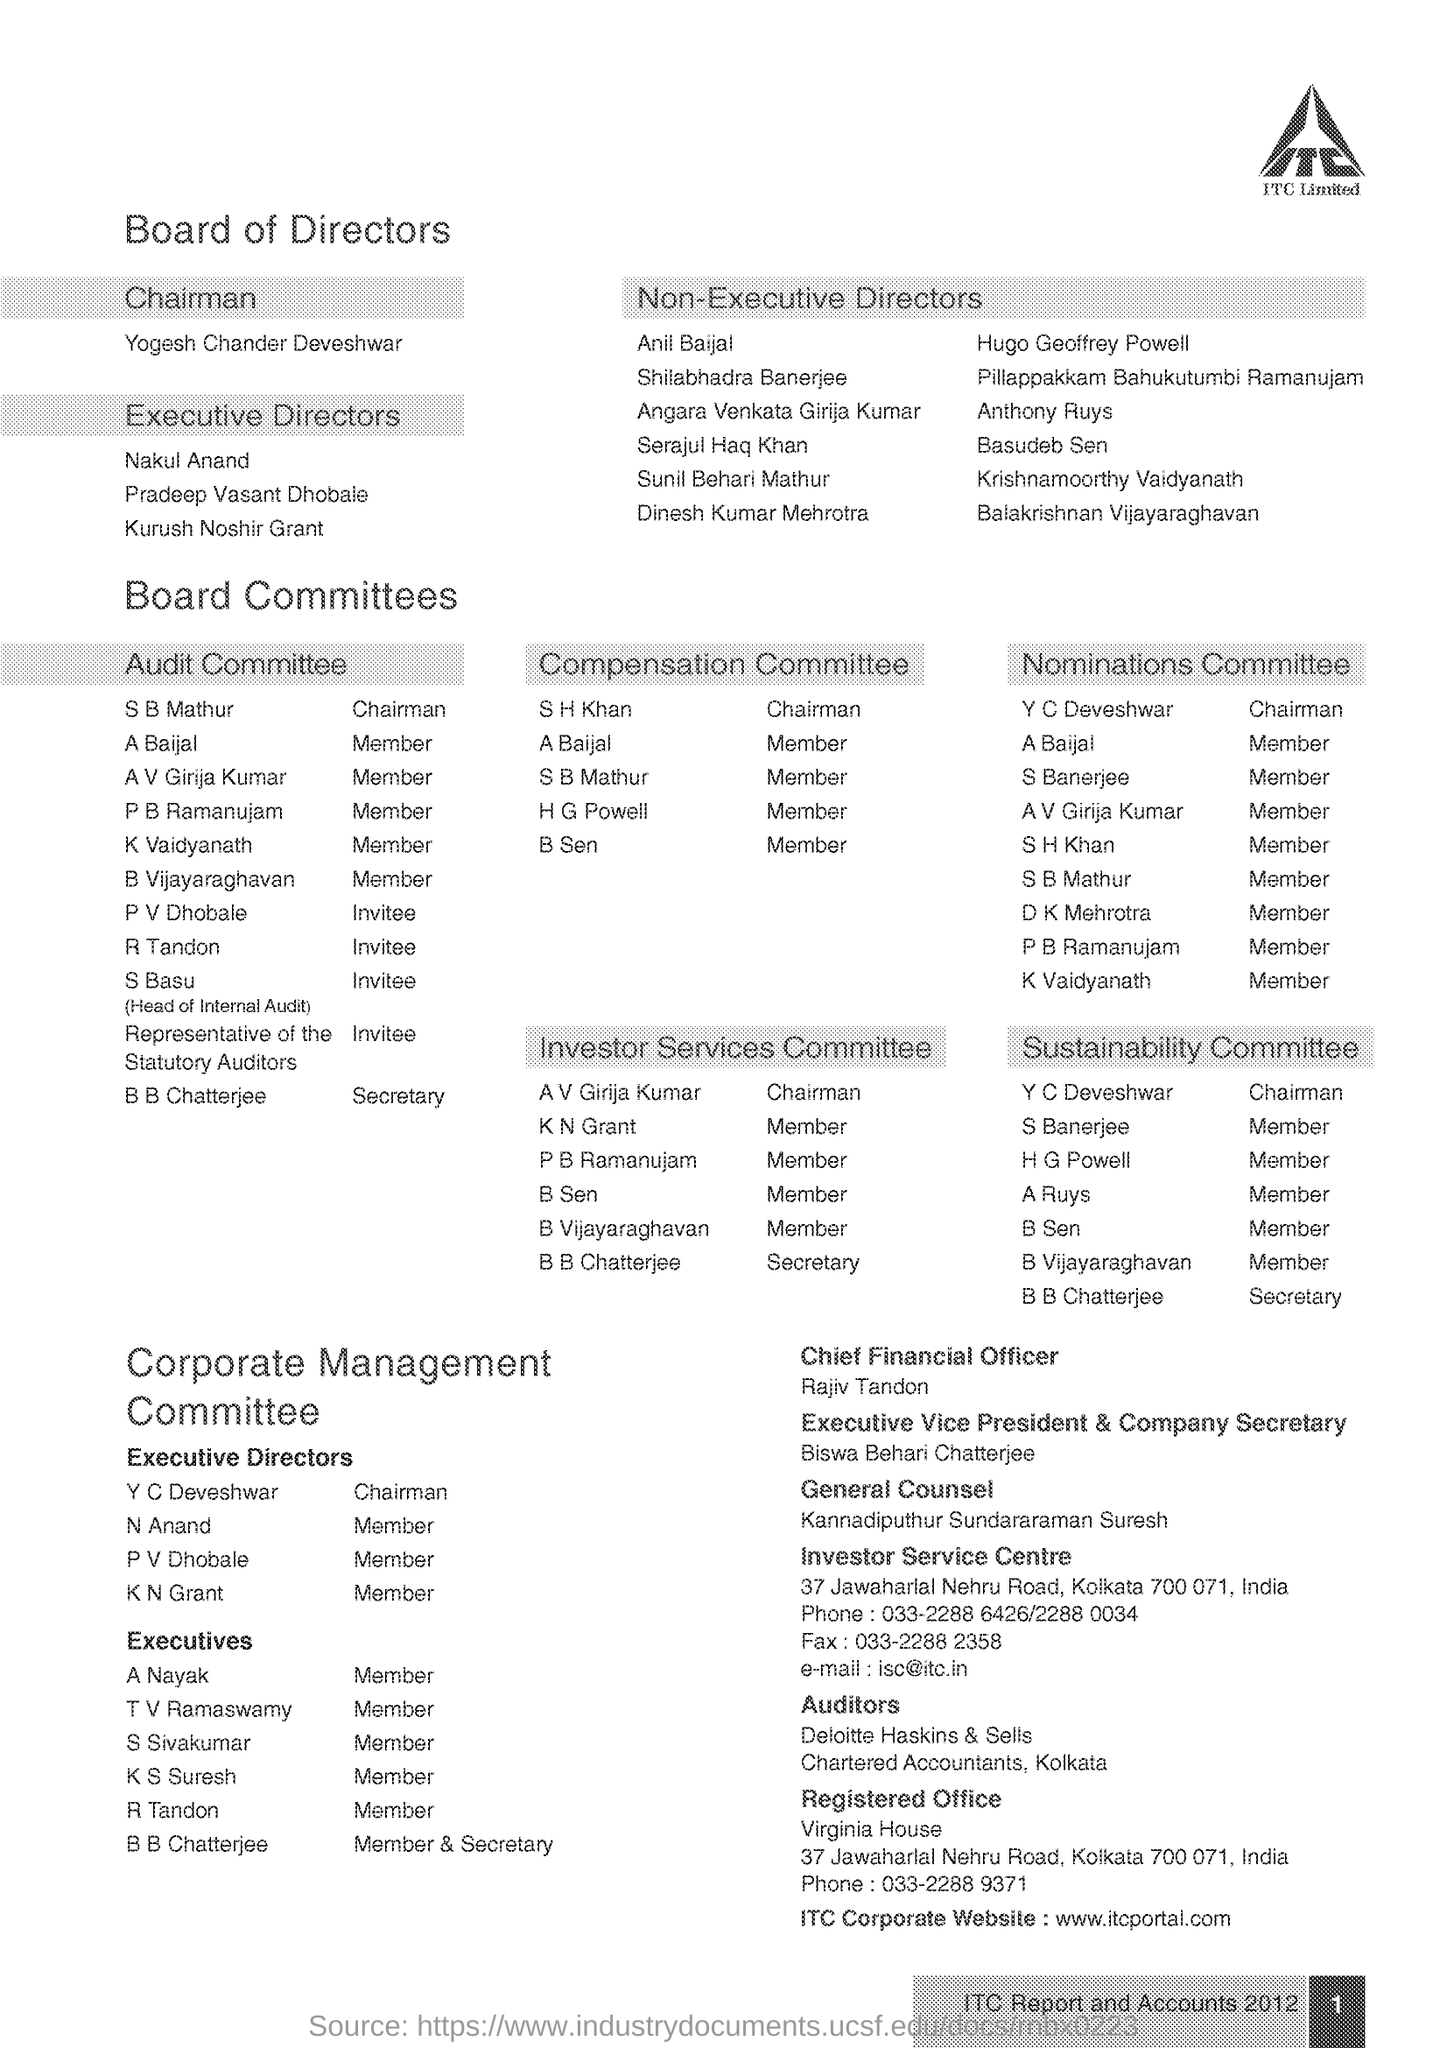Who is the Chief Financial Officer of ITC Limted?
Make the answer very short. Rajiv Tandon. What is the ITC Corporate Website given in the document?
Offer a terse response. Www.itcportal.com. What is the designation of  Biswa Behari Chatterjee?
Keep it short and to the point. Executive Vice President & Company Secretary. What is the Phone No of the Registered Office?
Your answer should be very brief. 033-2288 9371. Who is the Chairman of Audit Committee?
Your response must be concise. S B Mathur. What is the Fax no of the Investor Service Centre?
Your answer should be very brief. 033-2288 2358. Who is the Chairman, Board of Directors?
Give a very brief answer. Yogesh Chander Deveshwar. What is the page no mentioned in this document?
Offer a terse response. 1. Who is the General Counsel as per the document?
Your answer should be compact. Kannadiputhur Sundararaman Suresh. 